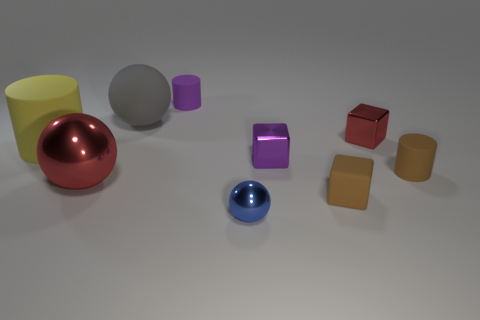Subtract all tiny blue metallic spheres. How many spheres are left? 2 Subtract all brown cylinders. How many cylinders are left? 2 Subtract 1 cylinders. How many cylinders are left? 2 Subtract all blocks. How many objects are left? 6 Add 4 brown cubes. How many brown cubes are left? 5 Add 5 cylinders. How many cylinders exist? 8 Subtract 0 blue cylinders. How many objects are left? 9 Subtract all yellow cubes. Subtract all purple cylinders. How many cubes are left? 3 Subtract all tiny metal objects. Subtract all large red rubber balls. How many objects are left? 6 